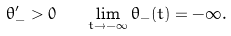<formula> <loc_0><loc_0><loc_500><loc_500>\theta _ { - } ^ { \prime } > 0 \quad \lim _ { t \to - \infty } \theta _ { - } ( t ) = - \infty .</formula> 